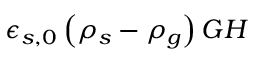<formula> <loc_0><loc_0><loc_500><loc_500>\epsilon _ { s , 0 } \left ( \rho _ { s } - \rho _ { g } \right ) G H</formula> 